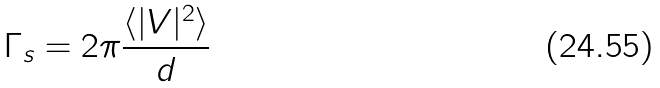Convert formula to latex. <formula><loc_0><loc_0><loc_500><loc_500>\Gamma _ { s } = 2 \pi \frac { \langle | V | ^ { 2 } \rangle } { d }</formula> 